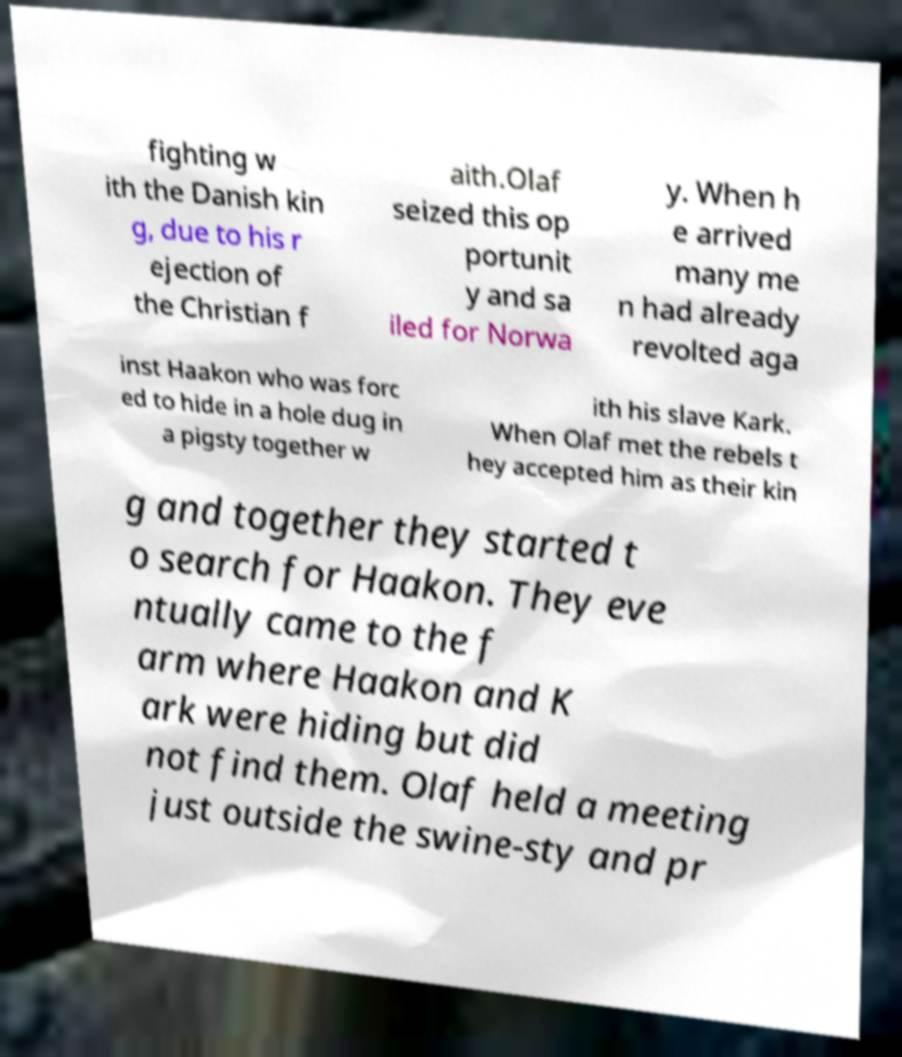Please identify and transcribe the text found in this image. fighting w ith the Danish kin g, due to his r ejection of the Christian f aith.Olaf seized this op portunit y and sa iled for Norwa y. When h e arrived many me n had already revolted aga inst Haakon who was forc ed to hide in a hole dug in a pigsty together w ith his slave Kark. When Olaf met the rebels t hey accepted him as their kin g and together they started t o search for Haakon. They eve ntually came to the f arm where Haakon and K ark were hiding but did not find them. Olaf held a meeting just outside the swine-sty and pr 